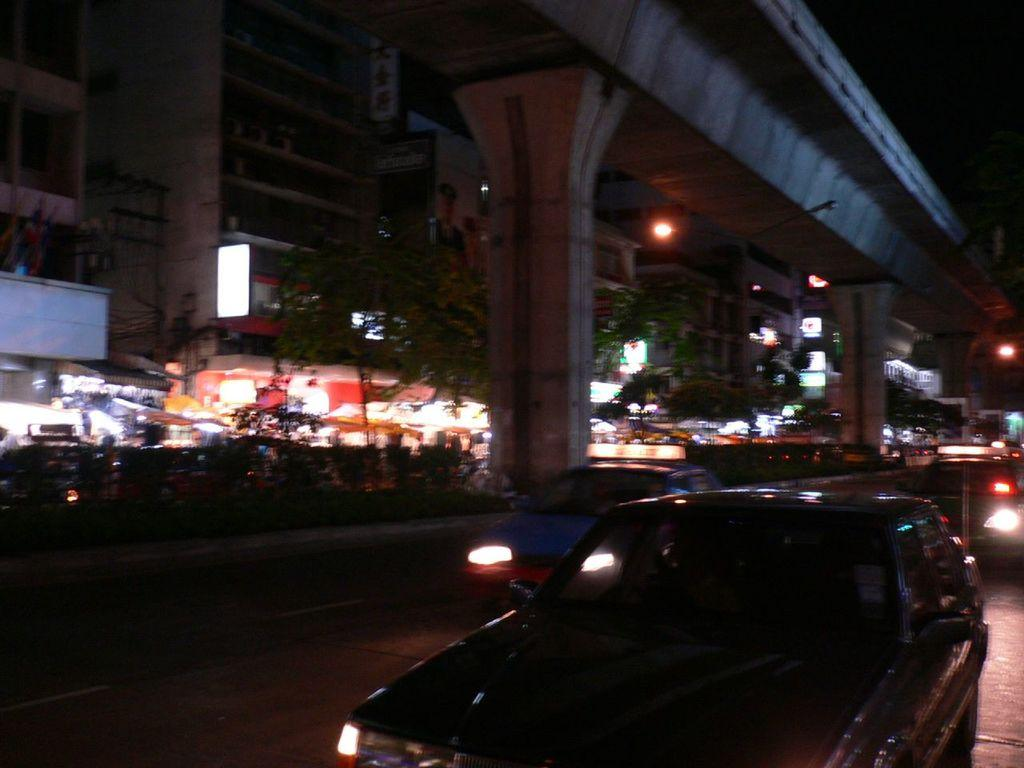What structure can be seen in the image? There is a bridge in the image. What is happening on the bridge or near it? There are vehicles on the road in the image. What can be seen illuminating the scene in the image? There are lights visible in the image. What type of man-made structure is present in the image? There is at least one building in the image. What type of natural elements are present in the image? Trees are present in the image. What type of zinc is used to construct the bridge in the image? There is no information about the type of zinc used in the construction of the bridge in the image. 